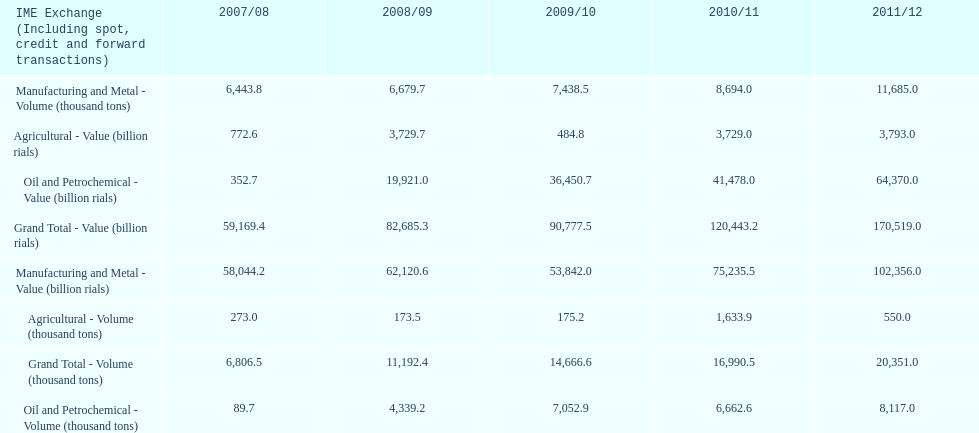What year saw the greatest value for manufacturing and metal in iran? 2011/12. 